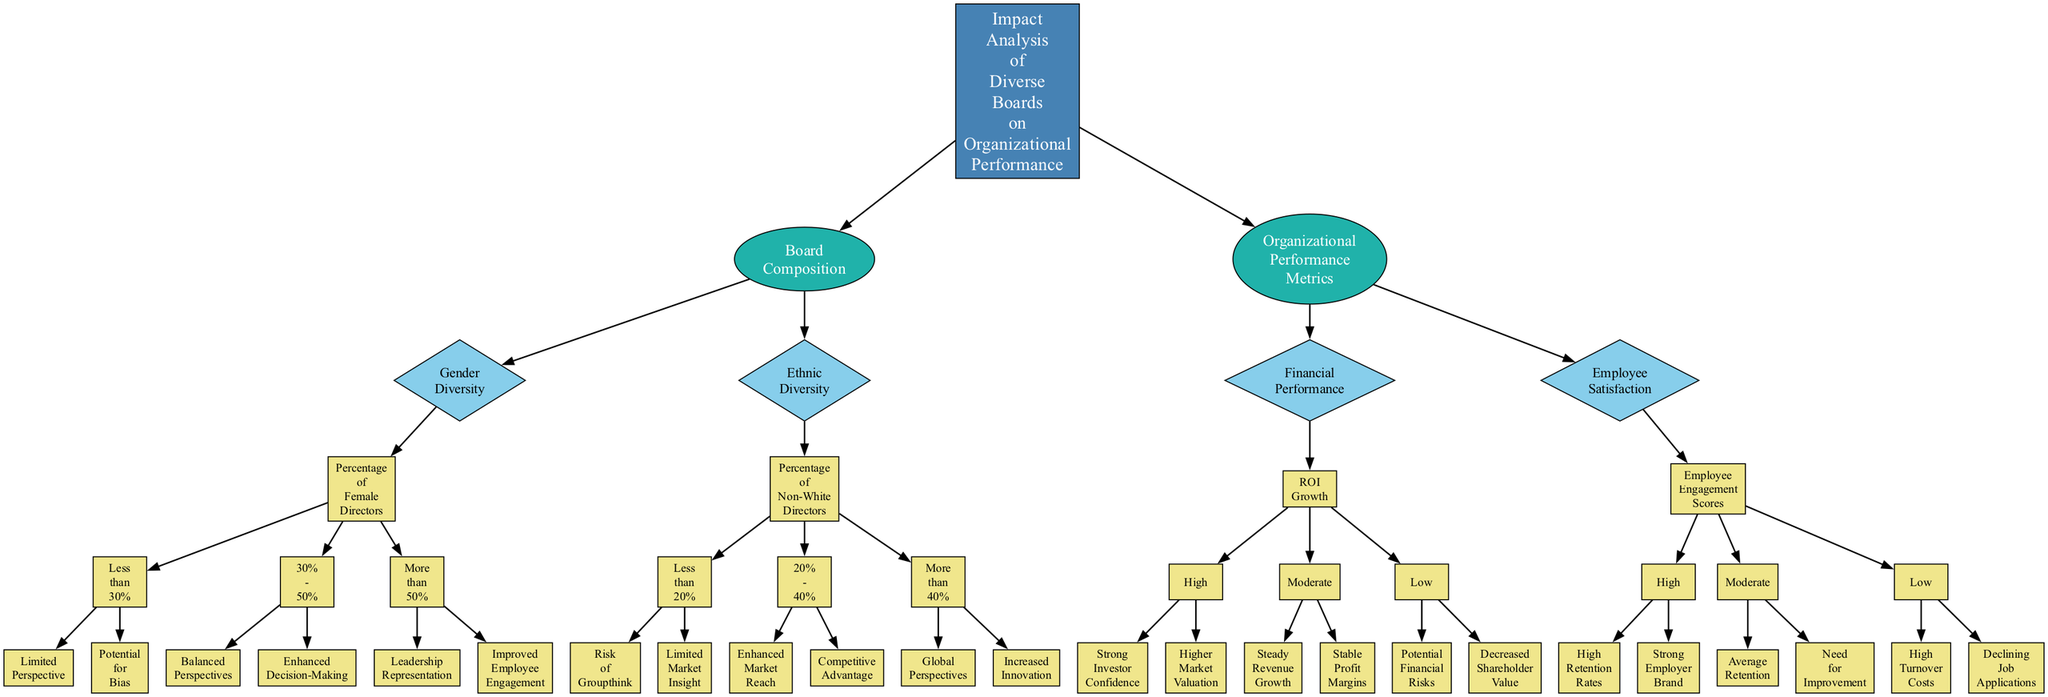What is the main focus of the diagram? The root node of the diagram is "Impact Analysis of Diverse Boards on Organizational Performance," which indicates that the entire focus of the diagram revolves around analyzing the influence that diverse boards have on how organizations perform.
Answer: Impact Analysis of Diverse Boards on Organizational Performance How many main branches are there in the diagram? The diagram has two main branches stemming from the root: one focusing on "Board Composition" and the other on "Organizational Performance Metrics." This indicates that there are two primary areas addressed in the analysis.
Answer: Two What are the percentages for female directors associated with "Balanced Perspectives"? The node labeled "Balanced Perspectives" is linked to the range of "30% - 50%" for the percentage of female directors, showing that this level of gender diversity contributes positively to the board's perspectives.
Answer: 30% - 50% What does a percentage of non-white directors that is less than 20% indicate? According to the diagram, a percentage of non-white directors that is less than 20% leads to "Risk of Groupthink" and "Limited Market Insight." These results signify potential drawbacks of lacking ethnic diversity in the board.
Answer: Risk of Groupthink In "Financial Performance," what does a high ROI growth indicate? The diagram illustrates that a high ROI growth corresponds to "Strong Investor Confidence" and "Higher Market Valuation." This shows that a strong financial performance can positively influence investor perception and market standing.
Answer: Strong Investor Confidence If a company has a high Employee Engagement score, what are the expected outcomes? The node for high Employee Engagement scores suggests outcomes such as "High Retention Rates" and "Strong Employer Brand," indicating the positive relationship between employee engagement and organizational success.
Answer: High Retention Rates What is the potential consequence of having low employee satisfaction? The diagram indicates that low employee satisfaction can result in "High Turnover Costs" and "Declining Job Applications," highlighting the adverse effects of failing to maintain employee satisfaction within the organization.
Answer: High Turnover Costs Which node leads to the "Increased Innovation"? "Increased Innovation" is reached through the node that states "More than 40%" for the percentage of non-white directors, emphasizing how higher ethnic diversity can enhance creative output within the organization.
Answer: More than 40% What type of node is "Percentage of Female Directors"? The node "Percentage of Female Directors" is categorized as a diamond-shaped node in the diagram, which generally denotes decision points or classifications within the tree structure.
Answer: Diamond-shaped node 